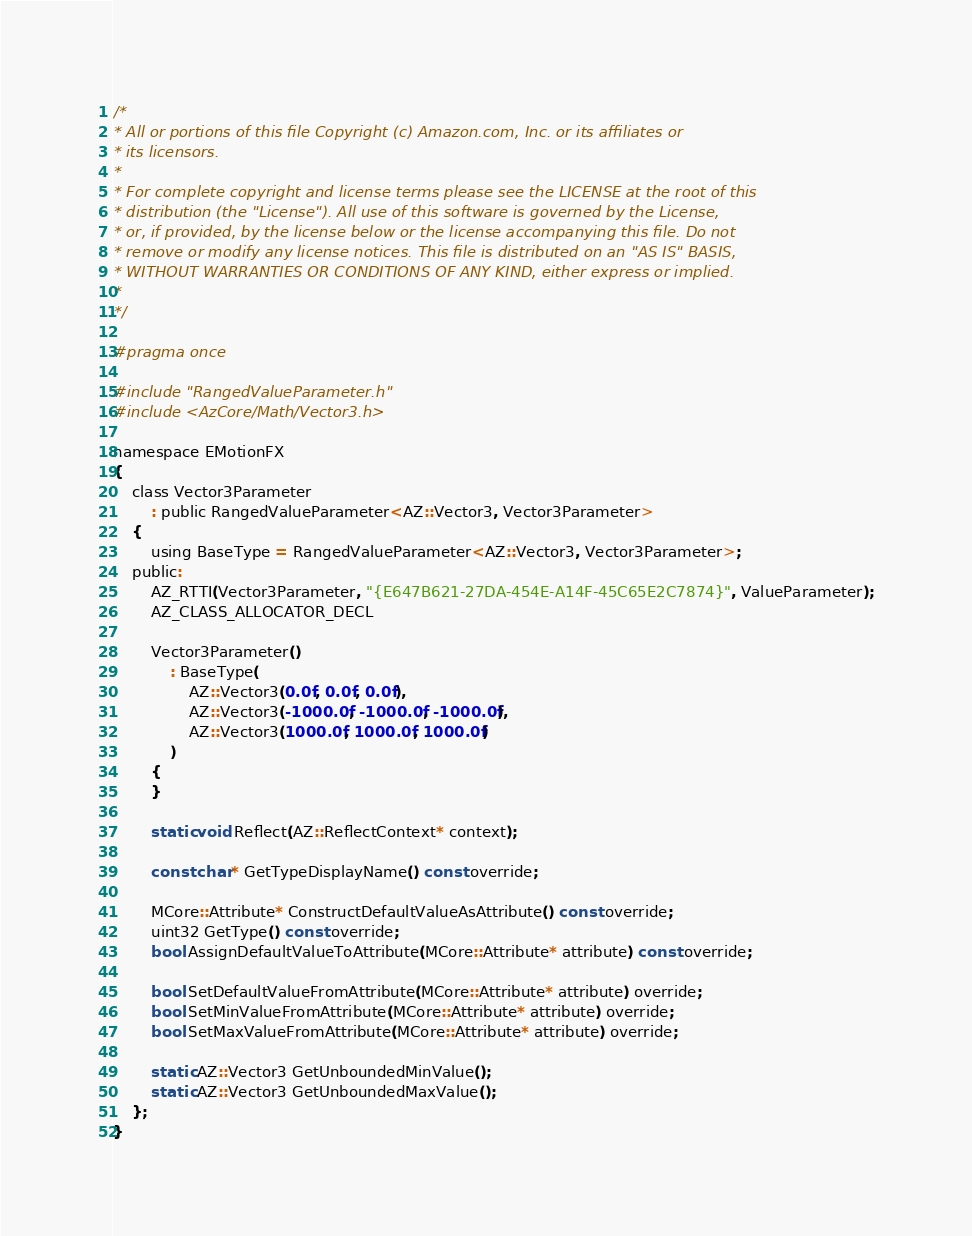Convert code to text. <code><loc_0><loc_0><loc_500><loc_500><_C_>/*
* All or portions of this file Copyright (c) Amazon.com, Inc. or its affiliates or
* its licensors.
*
* For complete copyright and license terms please see the LICENSE at the root of this
* distribution (the "License"). All use of this software is governed by the License,
* or, if provided, by the license below or the license accompanying this file. Do not
* remove or modify any license notices. This file is distributed on an "AS IS" BASIS,
* WITHOUT WARRANTIES OR CONDITIONS OF ANY KIND, either express or implied.
*
*/

#pragma once

#include "RangedValueParameter.h"
#include <AzCore/Math/Vector3.h>

namespace EMotionFX
{
    class Vector3Parameter
        : public RangedValueParameter<AZ::Vector3, Vector3Parameter>
    {
        using BaseType = RangedValueParameter<AZ::Vector3, Vector3Parameter>;
    public:
        AZ_RTTI(Vector3Parameter, "{E647B621-27DA-454E-A14F-45C65E2C7874}", ValueParameter);
        AZ_CLASS_ALLOCATOR_DECL

        Vector3Parameter()
            : BaseType(
                AZ::Vector3(0.0f, 0.0f, 0.0f),
                AZ::Vector3(-1000.0f, -1000.0f, -1000.0f),
                AZ::Vector3(1000.0f, 1000.0f, 1000.0f)
            )
        {
        }

        static void Reflect(AZ::ReflectContext* context);

        const char* GetTypeDisplayName() const override;

        MCore::Attribute* ConstructDefaultValueAsAttribute() const override;
        uint32 GetType() const override;
        bool AssignDefaultValueToAttribute(MCore::Attribute* attribute) const override;

        bool SetDefaultValueFromAttribute(MCore::Attribute* attribute) override;
        bool SetMinValueFromAttribute(MCore::Attribute* attribute) override;
        bool SetMaxValueFromAttribute(MCore::Attribute* attribute) override;

        static AZ::Vector3 GetUnboundedMinValue();
        static AZ::Vector3 GetUnboundedMaxValue();
    };
}
</code> 